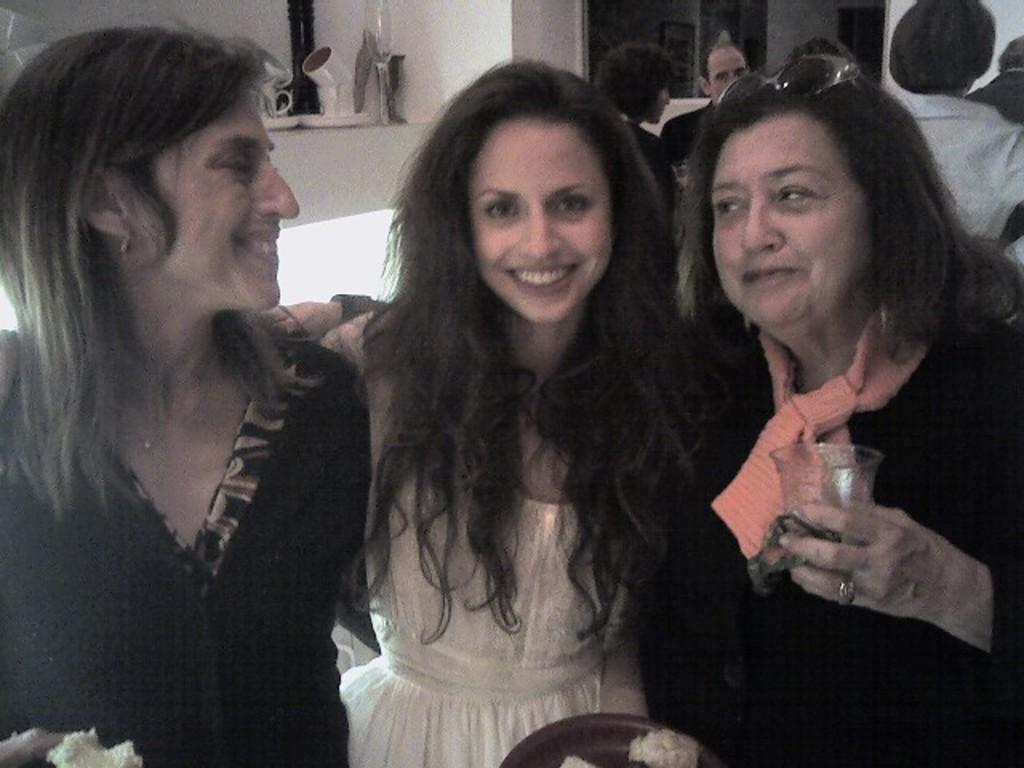Please provide a concise description of this image. This pictures shows few woman standing with smile on their faces and we see a woman holding a glass in her hand and sunglasses on her head and we see few people standing on the back. 